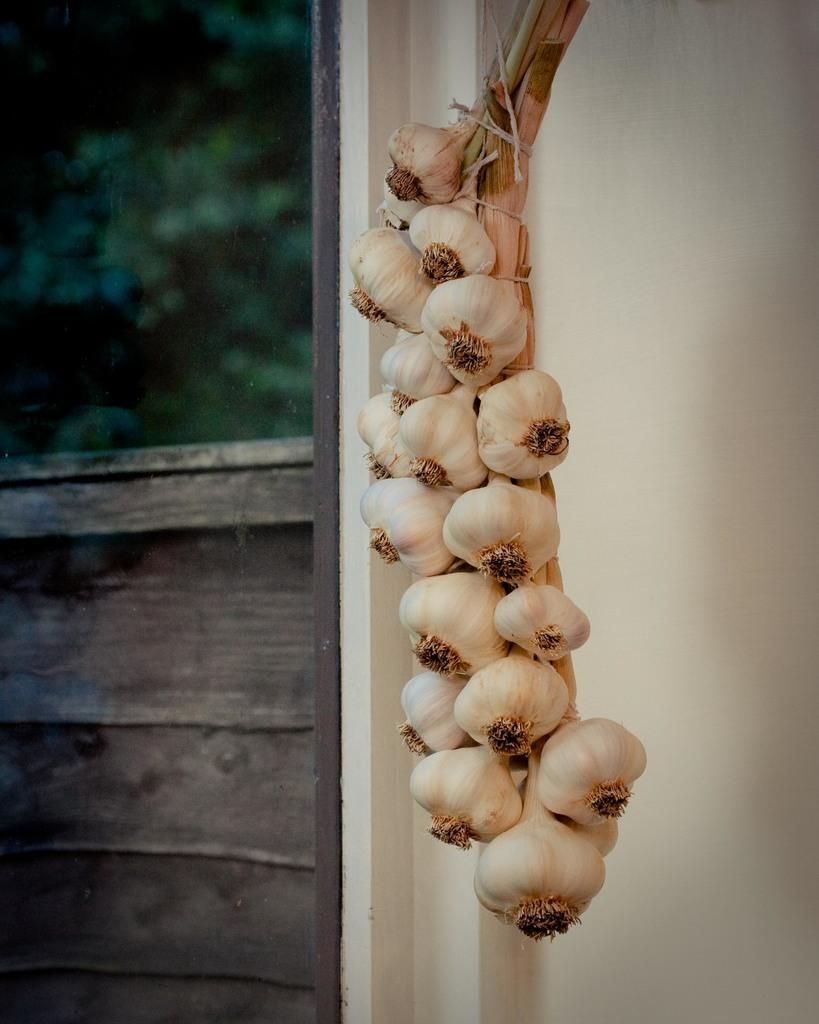What type of food item is present in the image? There are garlic cloves in the image. What is the color of the garlic cloves? The garlic cloves are white in color. How are the garlic cloves attached to something else? The garlic cloves are tied to an object. What can be seen in the left top corner of the image? There are trees in the left top corner of the image. Can you tell me how many potatoes are in the image? There are no potatoes present in the image; it features garlic cloves. What type of bird is sitting on the garlic cloves in the image? There is no bird, specifically a wren, present in the image. 